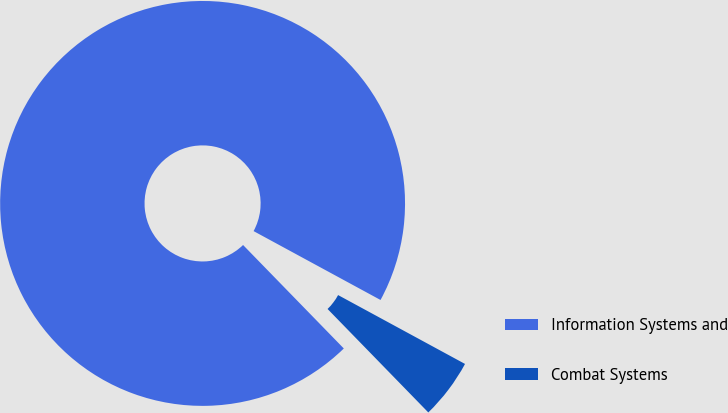Convert chart. <chart><loc_0><loc_0><loc_500><loc_500><pie_chart><fcel>Information Systems and<fcel>Combat Systems<nl><fcel>95.2%<fcel>4.8%<nl></chart> 